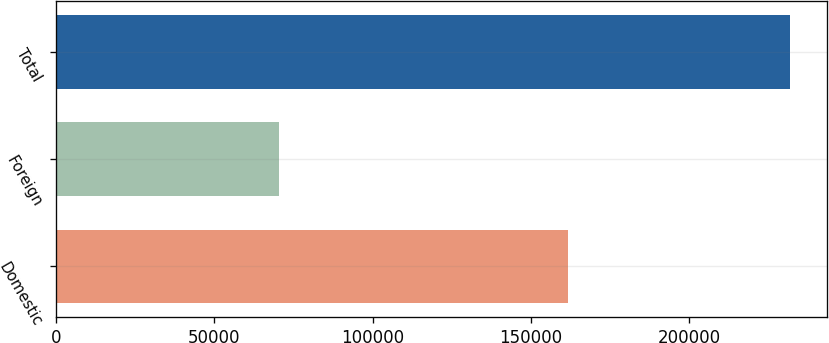Convert chart. <chart><loc_0><loc_0><loc_500><loc_500><bar_chart><fcel>Domestic<fcel>Foreign<fcel>Total<nl><fcel>161573<fcel>70301<fcel>231874<nl></chart> 